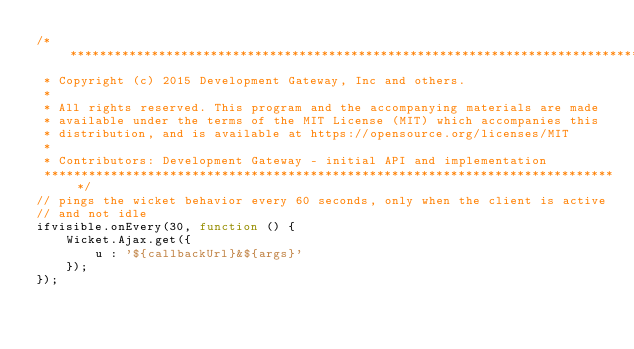<code> <loc_0><loc_0><loc_500><loc_500><_JavaScript_>/*******************************************************************************
 * Copyright (c) 2015 Development Gateway, Inc and others.
 * 
 * All rights reserved. This program and the accompanying materials are made
 * available under the terms of the MIT License (MIT) which accompanies this
 * distribution, and is available at https://opensource.org/licenses/MIT
 * 
 * Contributors: Development Gateway - initial API and implementation
 ******************************************************************************/
// pings the wicket behavior every 60 seconds, only when the client is active
// and not idle
ifvisible.onEvery(30, function () {
    Wicket.Ajax.get({
        u : '${callbackUrl}&${args}'
    });
});</code> 